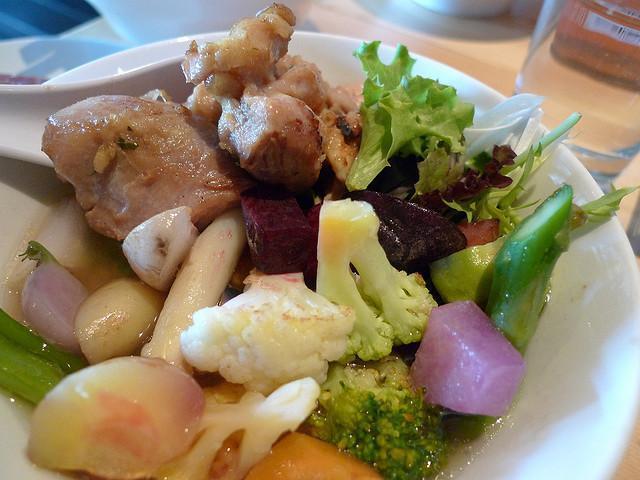How many broccolis are in the picture?
Give a very brief answer. 2. 